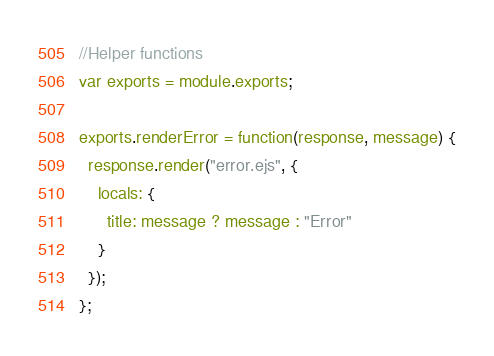Convert code to text. <code><loc_0><loc_0><loc_500><loc_500><_JavaScript_>//Helper functions
var exports = module.exports;

exports.renderError = function(response, message) {
  response.render("error.ejs", {
    locals: {
      title: message ? message : "Error"
    }
  });
};</code> 